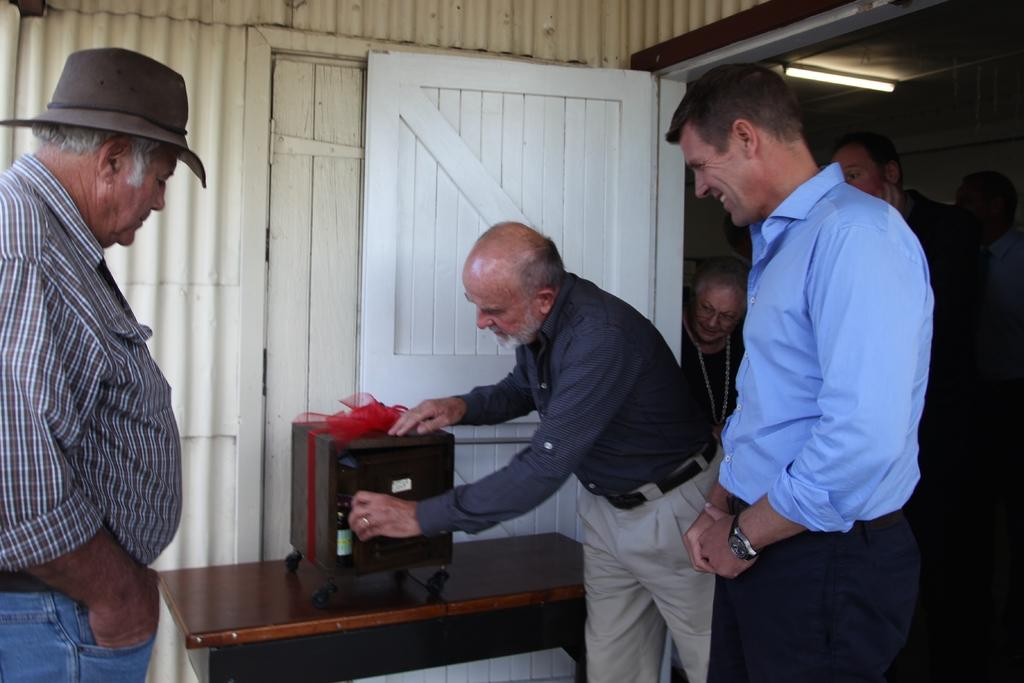What can be seen in the image involving people? There are people standing in the image. What is present in the image that might be used for placing items or eating? There is a table in the image. What is on the table in the image? There is an object on the table. What can be seen in the background of the image? There is light visible in the background, as well as a door and a wall. What type of flame can be seen coming from the bun in the image? There is no bun or flame present in the image. What is the condition of the door in the image? The provided facts do not mention the condition of the door, only that it is present in the background. 